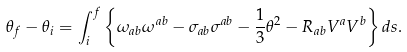<formula> <loc_0><loc_0><loc_500><loc_500>\theta _ { f } - \theta _ { i } = \int _ { i } ^ { f } \left \{ \omega _ { a b } \omega ^ { a b } - \sigma _ { a b } \sigma ^ { a b } - \frac { 1 } { 3 } \theta ^ { 2 } - R _ { a b } V ^ { a } V ^ { b } \right \} d s .</formula> 